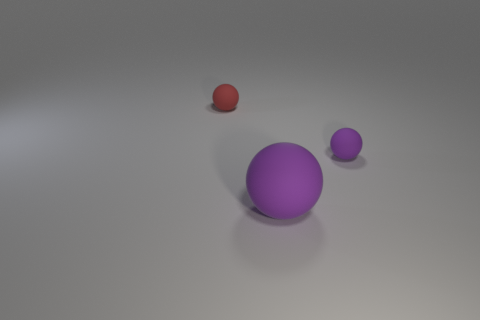Subtract all tiny purple rubber balls. How many balls are left? 2 Subtract all red cylinders. How many purple balls are left? 2 Add 1 red objects. How many objects exist? 4 Subtract 1 balls. How many balls are left? 2 Subtract all red balls. How many balls are left? 2 Subtract 0 cyan cubes. How many objects are left? 3 Subtract all cyan spheres. Subtract all green cylinders. How many spheres are left? 3 Subtract all yellow metallic blocks. Subtract all large purple spheres. How many objects are left? 2 Add 1 red balls. How many red balls are left? 2 Add 2 tiny red balls. How many tiny red balls exist? 3 